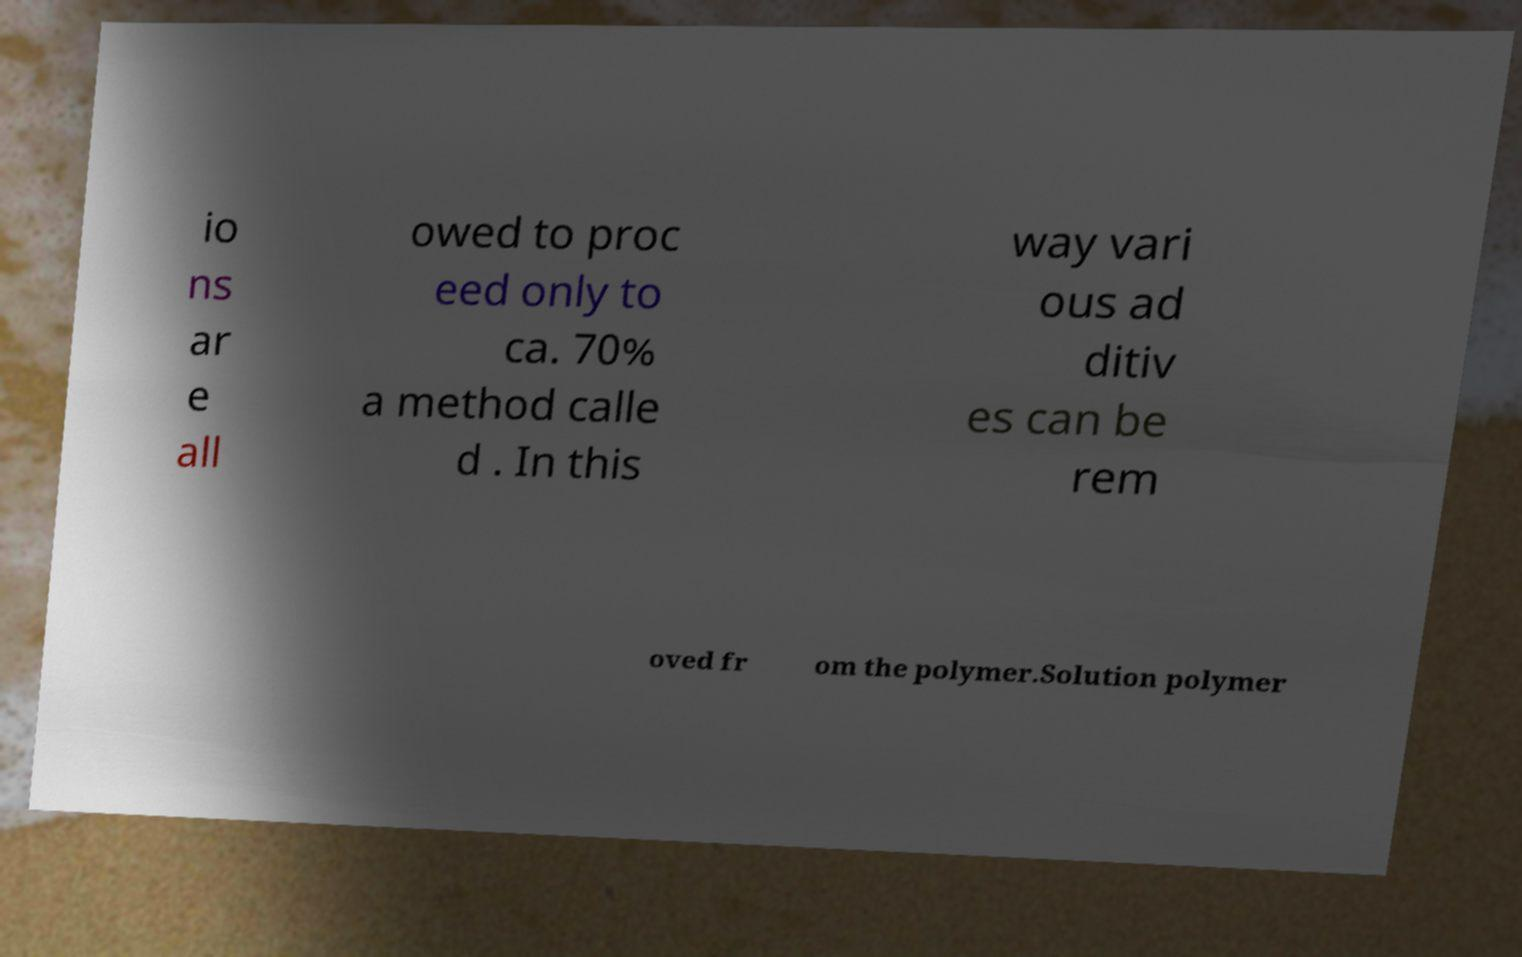There's text embedded in this image that I need extracted. Can you transcribe it verbatim? io ns ar e all owed to proc eed only to ca. 70% a method calle d . In this way vari ous ad ditiv es can be rem oved fr om the polymer.Solution polymer 